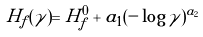Convert formula to latex. <formula><loc_0><loc_0><loc_500><loc_500>H _ { f } ( \gamma ) = H _ { f } ^ { 0 } + a _ { 1 } ( - \log \gamma ) ^ { a _ { 2 } }</formula> 